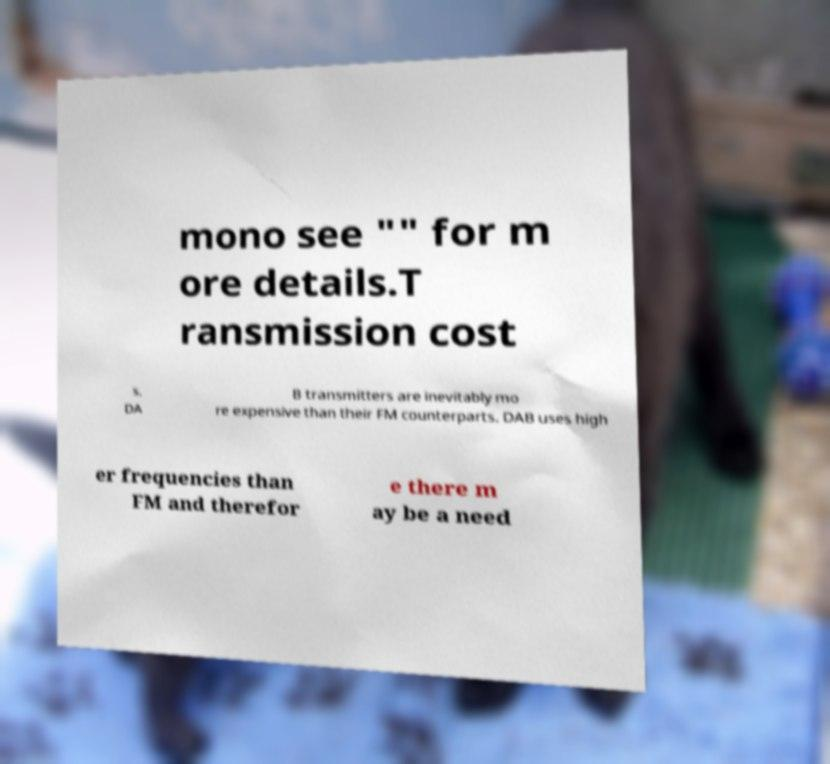What messages or text are displayed in this image? I need them in a readable, typed format. mono see "" for m ore details.T ransmission cost s. DA B transmitters are inevitably mo re expensive than their FM counterparts. DAB uses high er frequencies than FM and therefor e there m ay be a need 